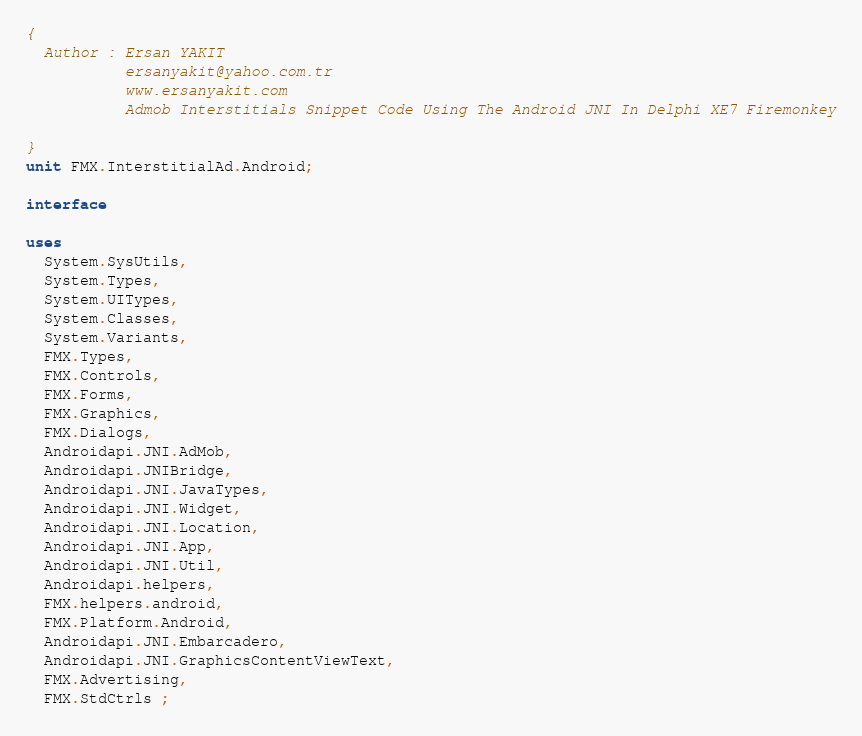<code> <loc_0><loc_0><loc_500><loc_500><_Pascal_>{
  Author : Ersan YAKIT
           ersanyakit@yahoo.com.tr
           www.ersanyakit.com
           Admob Interstitials Snippet Code Using The Android JNI In Delphi XE7 Firemonkey

}
unit FMX.InterstitialAd.Android;

interface

uses
  System.SysUtils,
  System.Types,
  System.UITypes,
  System.Classes,
  System.Variants,
  FMX.Types,
  FMX.Controls,
  FMX.Forms,
  FMX.Graphics,
  FMX.Dialogs,
  Androidapi.JNI.AdMob,
  Androidapi.JNIBridge,
  Androidapi.JNI.JavaTypes,
  Androidapi.JNI.Widget,
  Androidapi.JNI.Location,
  Androidapi.JNI.App,
  Androidapi.JNI.Util,
  Androidapi.helpers,
  FMX.helpers.android,
  FMX.Platform.Android,
  Androidapi.JNI.Embarcadero,
  Androidapi.JNI.GraphicsContentViewText,
  FMX.Advertising,
  FMX.StdCtrls ;</code> 